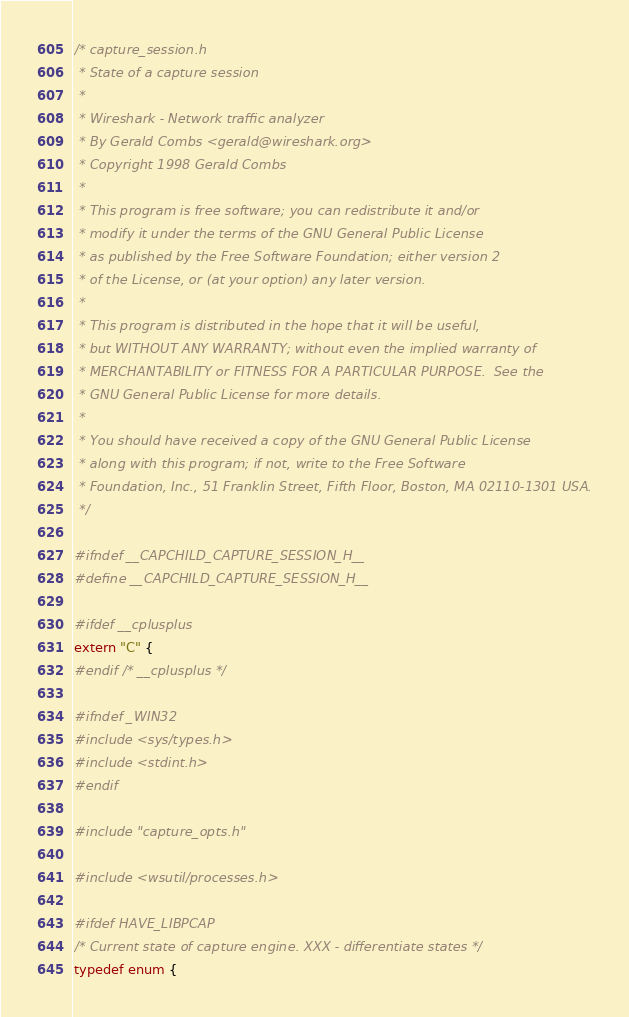<code> <loc_0><loc_0><loc_500><loc_500><_C_>/* capture_session.h
 * State of a capture session
 *
 * Wireshark - Network traffic analyzer
 * By Gerald Combs <gerald@wireshark.org>
 * Copyright 1998 Gerald Combs
 *
 * This program is free software; you can redistribute it and/or
 * modify it under the terms of the GNU General Public License
 * as published by the Free Software Foundation; either version 2
 * of the License, or (at your option) any later version.
 *
 * This program is distributed in the hope that it will be useful,
 * but WITHOUT ANY WARRANTY; without even the implied warranty of
 * MERCHANTABILITY or FITNESS FOR A PARTICULAR PURPOSE.  See the
 * GNU General Public License for more details.
 *
 * You should have received a copy of the GNU General Public License
 * along with this program; if not, write to the Free Software
 * Foundation, Inc., 51 Franklin Street, Fifth Floor, Boston, MA 02110-1301 USA.
 */

#ifndef __CAPCHILD_CAPTURE_SESSION_H__
#define __CAPCHILD_CAPTURE_SESSION_H__

#ifdef __cplusplus
extern "C" {
#endif /* __cplusplus */

#ifndef _WIN32
#include <sys/types.h>
#include <stdint.h>
#endif

#include "capture_opts.h"

#include <wsutil/processes.h>

#ifdef HAVE_LIBPCAP
/* Current state of capture engine. XXX - differentiate states */
typedef enum {</code> 